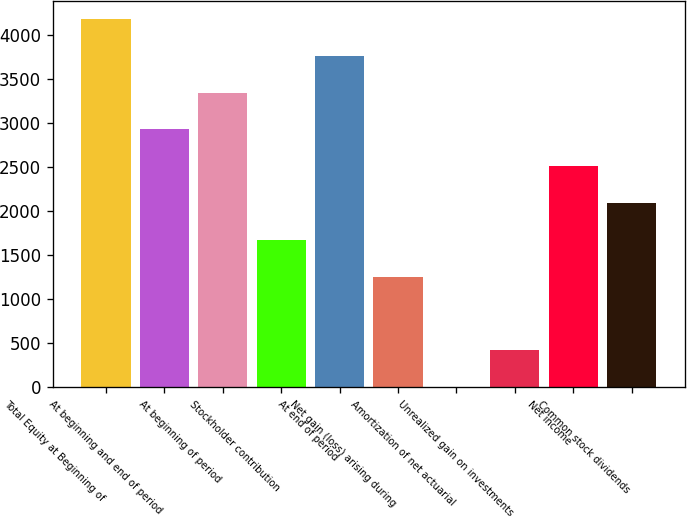Convert chart to OTSL. <chart><loc_0><loc_0><loc_500><loc_500><bar_chart><fcel>Total Equity at Beginning of<fcel>At beginning and end of period<fcel>At beginning of period<fcel>Stockholder contribution<fcel>At end of period<fcel>Net gain (loss) arising during<fcel>Amortization of net actuarial<fcel>Unrealized gain on investments<fcel>Net income<fcel>Common stock dividends<nl><fcel>4180<fcel>2926.3<fcel>3344.2<fcel>1672.6<fcel>3762.1<fcel>1254.7<fcel>1<fcel>418.9<fcel>2508.4<fcel>2090.5<nl></chart> 